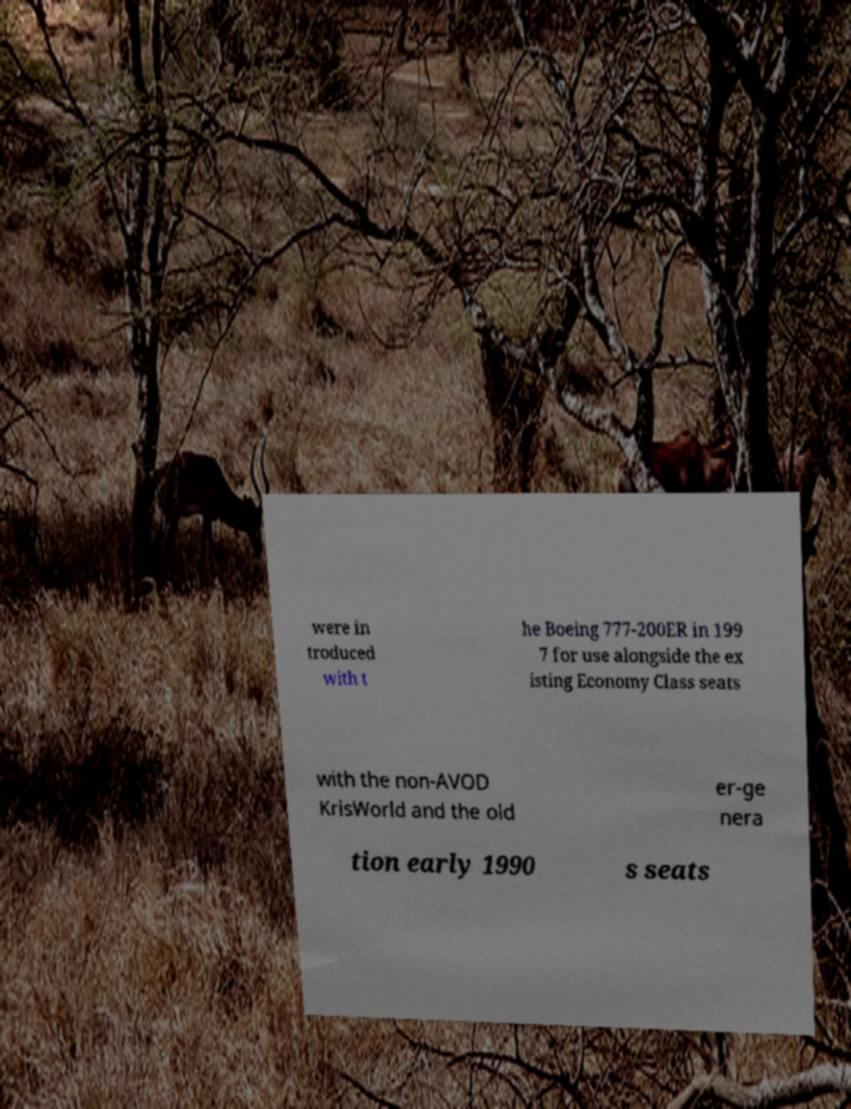What messages or text are displayed in this image? I need them in a readable, typed format. were in troduced with t he Boeing 777-200ER in 199 7 for use alongside the ex isting Economy Class seats with the non-AVOD KrisWorld and the old er-ge nera tion early 1990 s seats 